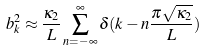<formula> <loc_0><loc_0><loc_500><loc_500>b _ { k } ^ { 2 } \approx \frac { \kappa _ { 2 } } { L } \sum _ { n = - \infty } ^ { \infty } \delta ( k - n \frac { \pi \sqrt { \kappa _ { 2 } } } { L } )</formula> 